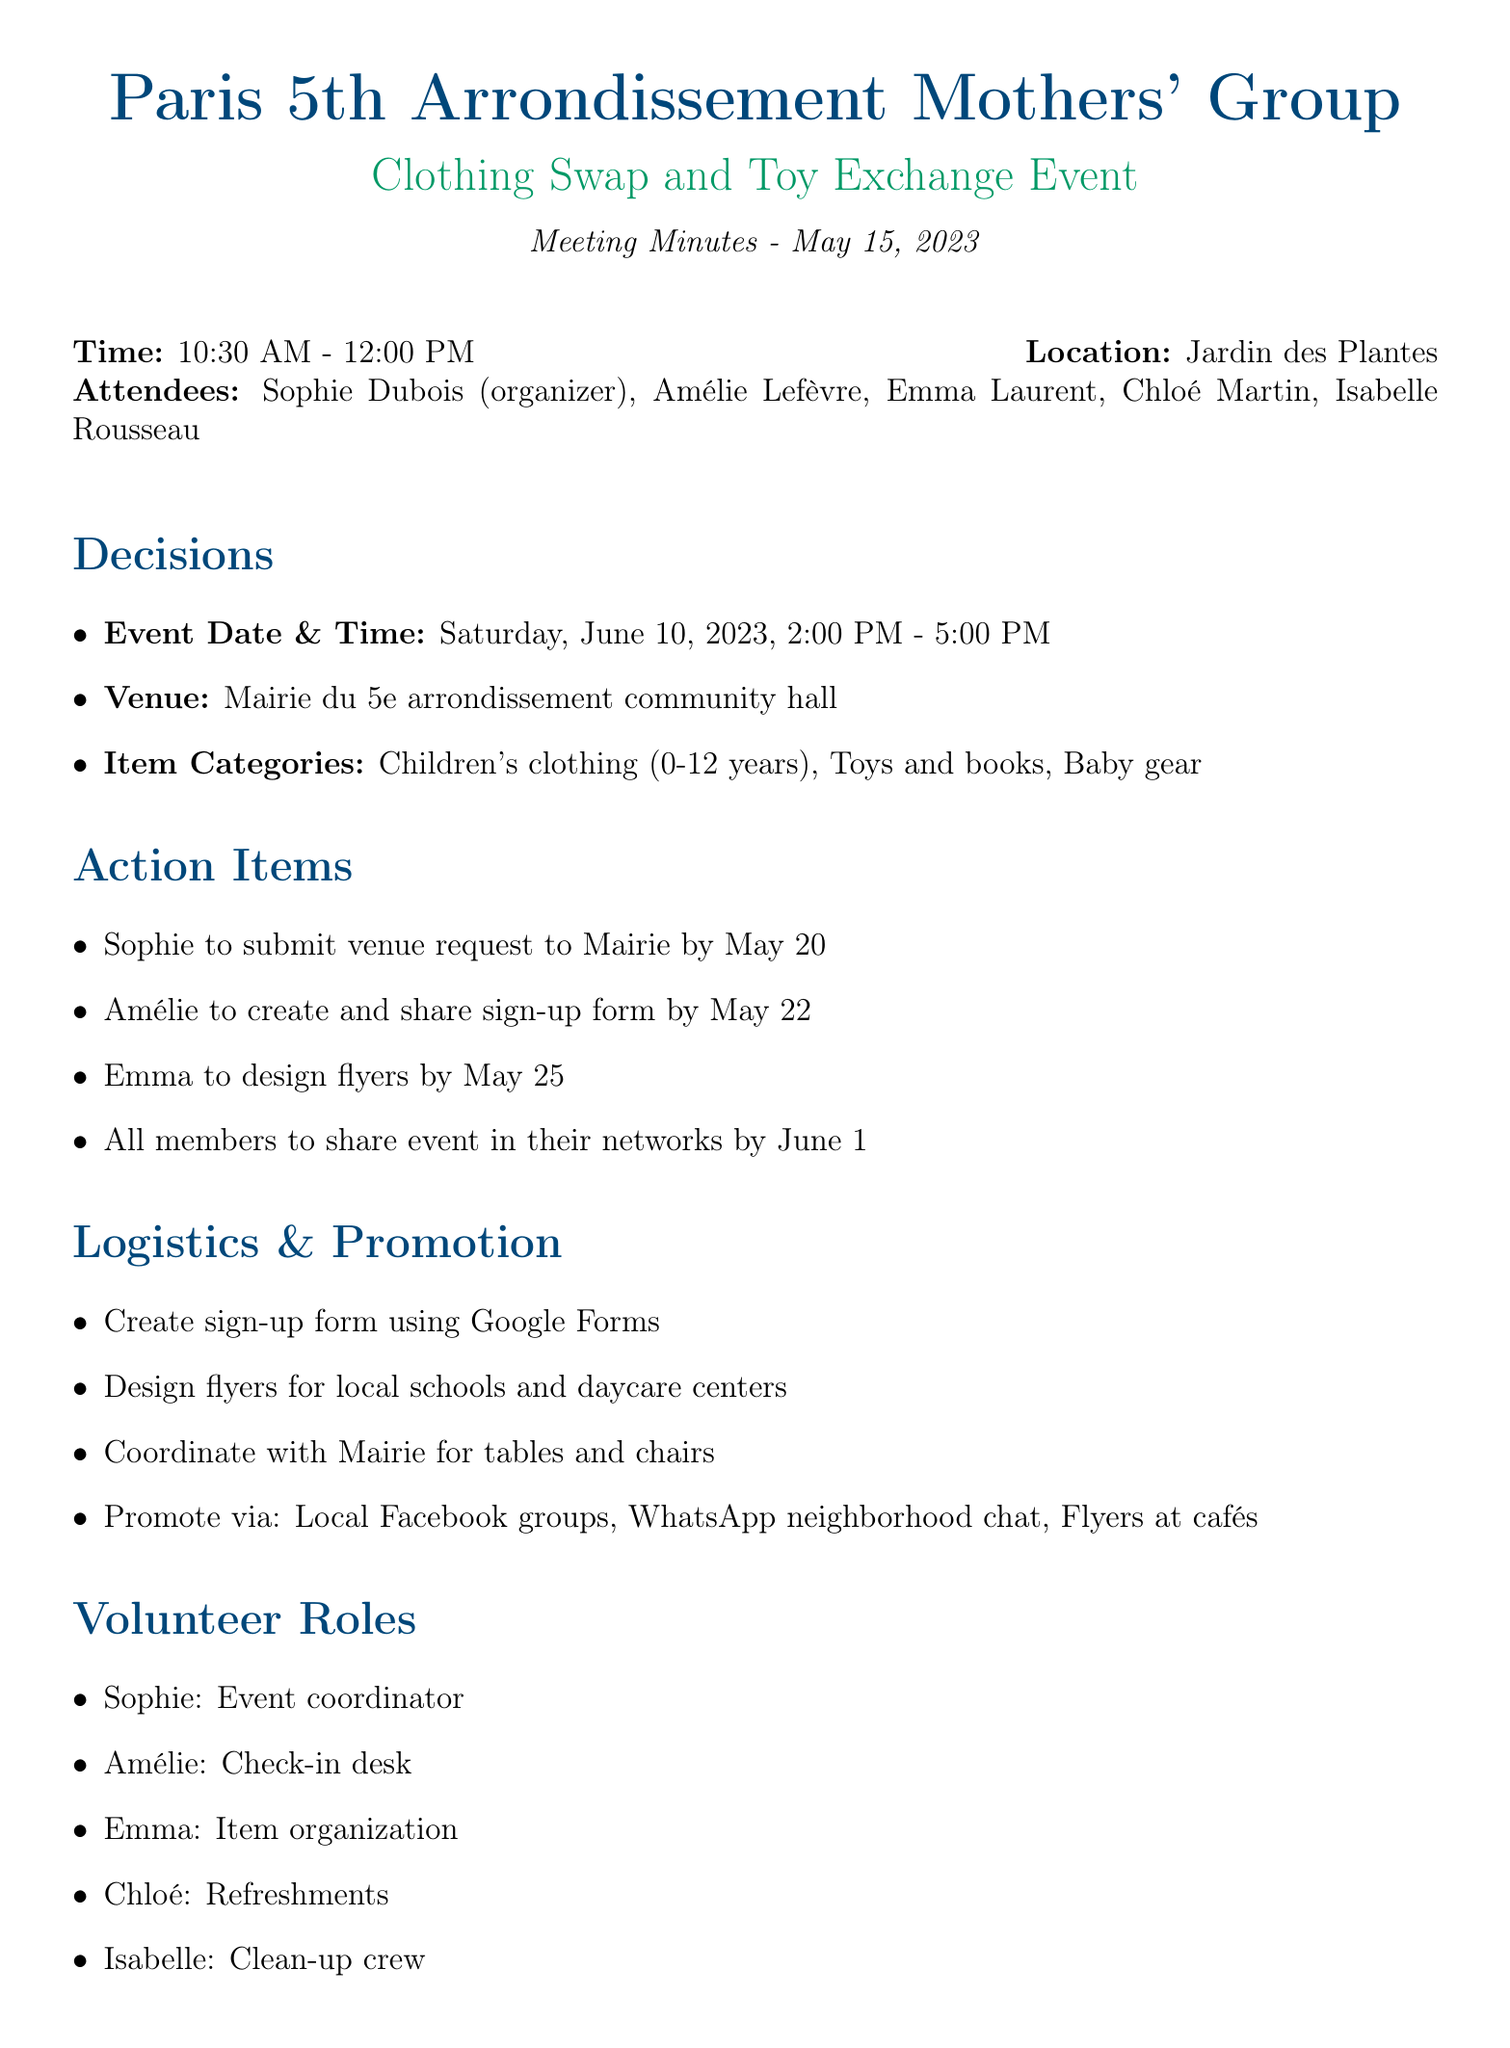What is the date of the event? The date and time of the event is mentioned in the decisions section of the document, which states June 10, 2023.
Answer: June 10, 2023 Who is the event coordinator? The volunteer roles section specifies that Sophie is responsible for coordinating the event.
Answer: Sophie What is the total budget for printing costs? The budget section lists the printing costs as €30.
Answer: €30 Where will the event take place? The venue decision states that the event will be held at the Mairie du 5e arrondissement community hall.
Answer: Mairie du 5e arrondissement community hall What channels will be used for promotion? The promotion section outlines the channels, including local Facebook groups, WhatsApp neighborhood chat, and flyers at cafés.
Answer: Local Facebook groups, WhatsApp neighborhood chat, Flyers at cafés How many categories of items are specified for the swap? The item categories section lists three types of items: clothing, toys and books, and baby gear.
Answer: Three What is the next meeting date? The document specifies the next meeting date in the final section, which states June 1, 2023.
Answer: June 1, 2023 What role is assigned to Amélie? The volunteer roles section indicates that Amélie is assigned to the check-in desk.
Answer: Check-in desk 